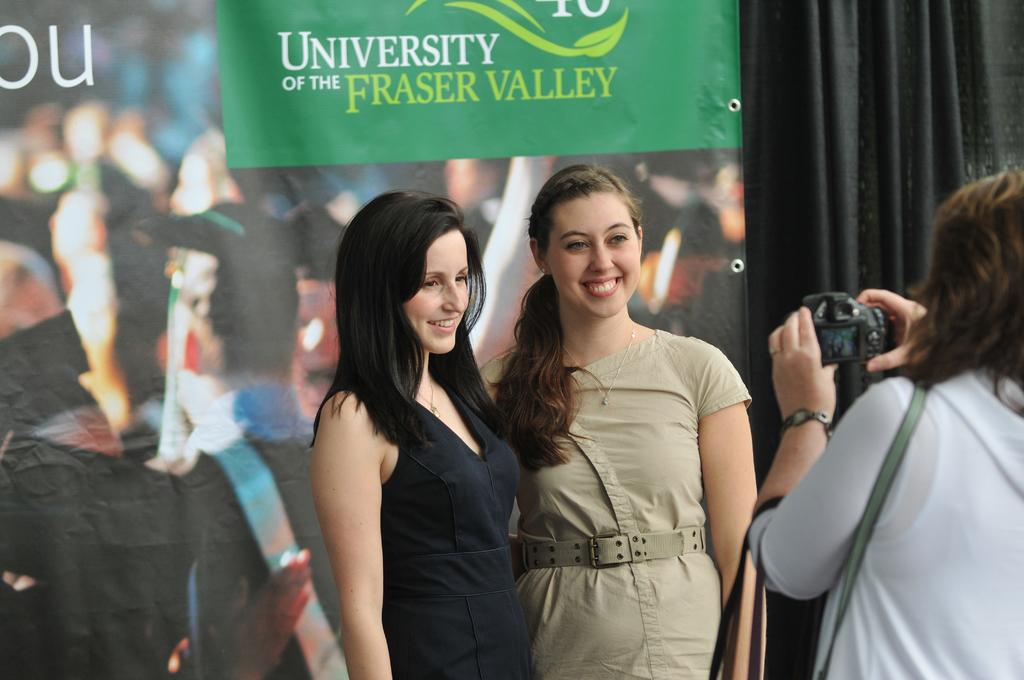What can be observed about the people in the image? There are women standing in the image, and one of them is holding a camera. Can you describe the expressions on the women's faces? There are smiles on some faces in the image. What else can be seen in the background of the image? There is text or writing visible in the background of the image. What type of yard is visible in the image? There is no yard visible in the image. Can you tell me what the secretary is doing in the image? There is no secretary present in the image. 